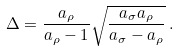<formula> <loc_0><loc_0><loc_500><loc_500>\Delta = \frac { a _ { \rho } } { a _ { \rho } - 1 } \sqrt { \frac { a _ { \sigma } a _ { \rho } } { a _ { \sigma } - a _ { \rho } } } \, .</formula> 